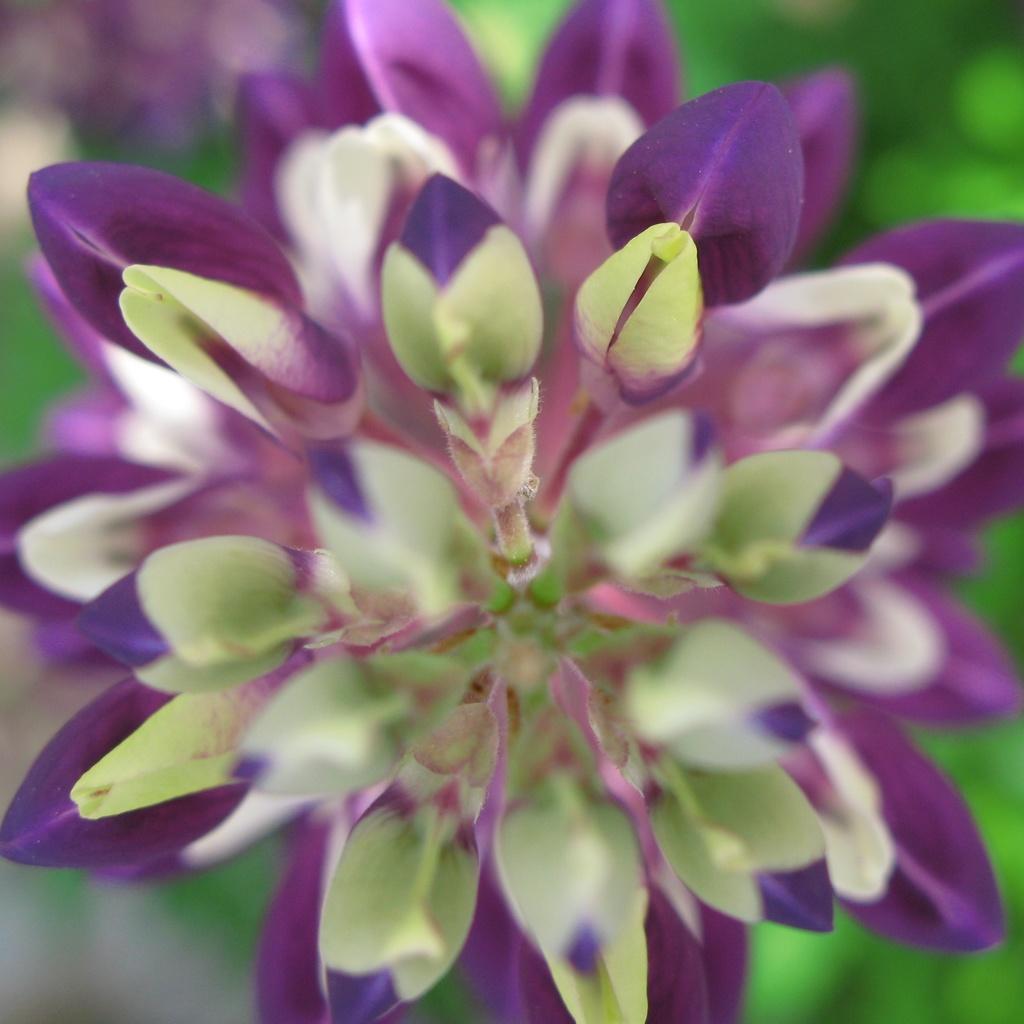In one or two sentences, can you explain what this image depicts? In this image, I can see a flower. These are the metals, which are violet and light green in color. The background looks blurry. 